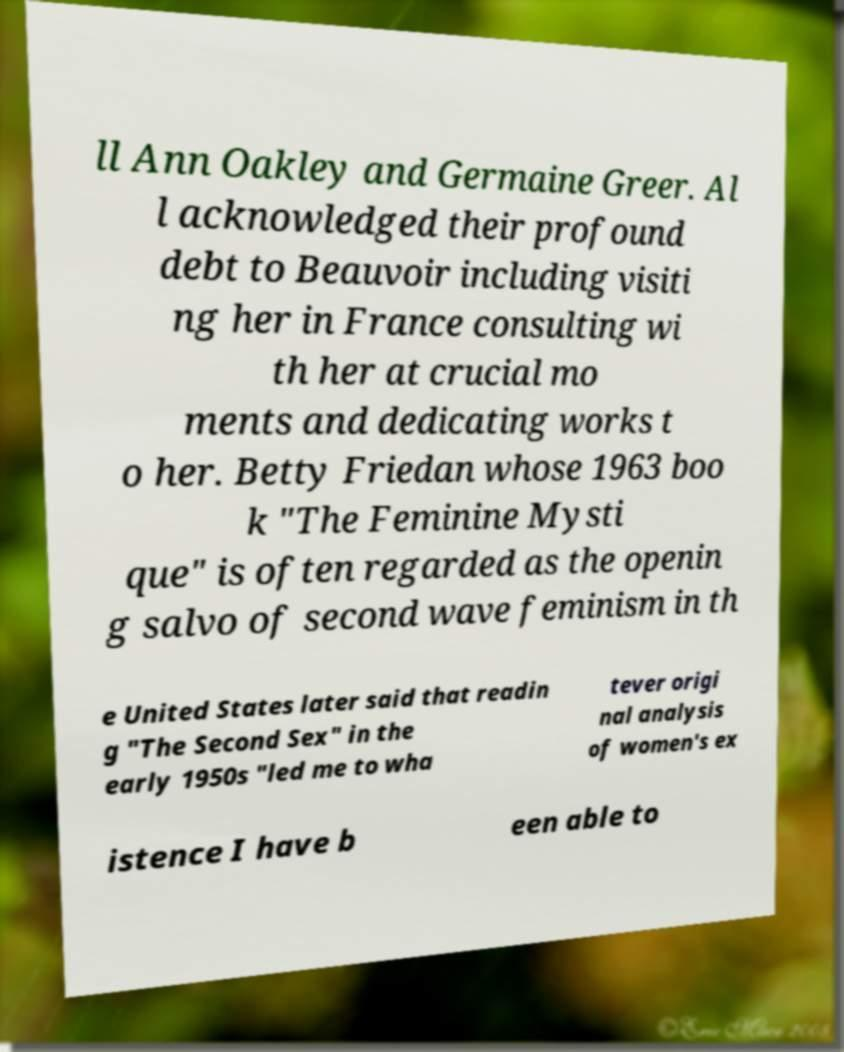Please read and relay the text visible in this image. What does it say? ll Ann Oakley and Germaine Greer. Al l acknowledged their profound debt to Beauvoir including visiti ng her in France consulting wi th her at crucial mo ments and dedicating works t o her. Betty Friedan whose 1963 boo k "The Feminine Mysti que" is often regarded as the openin g salvo of second wave feminism in th e United States later said that readin g "The Second Sex" in the early 1950s "led me to wha tever origi nal analysis of women's ex istence I have b een able to 